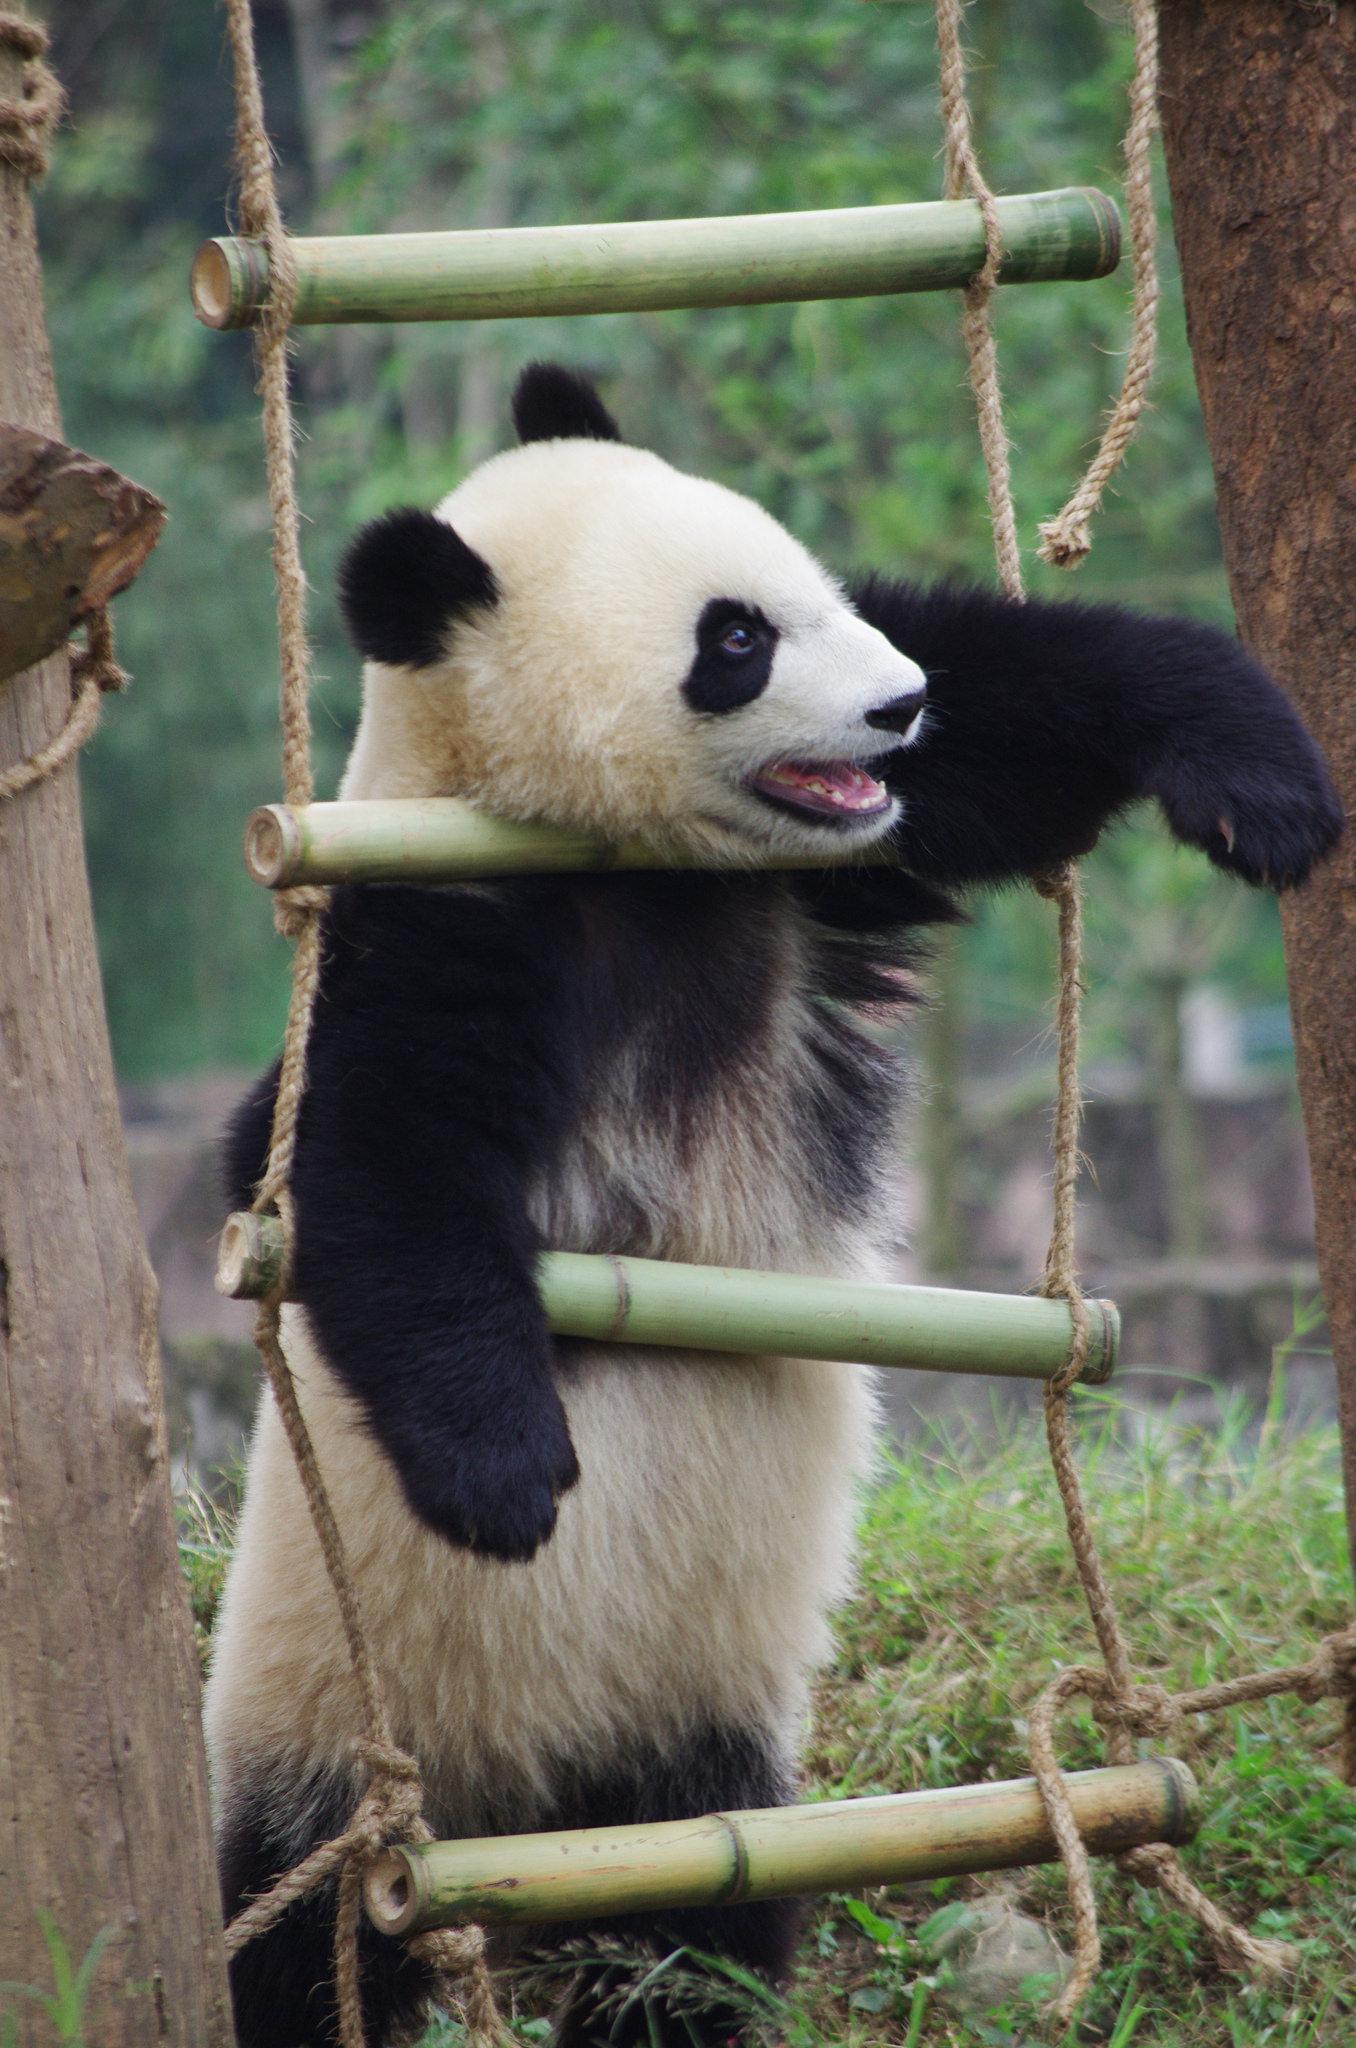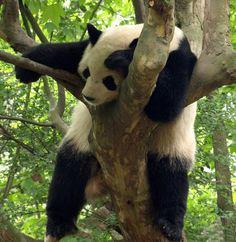The first image is the image on the left, the second image is the image on the right. Assess this claim about the two images: "The right image shows one panda draped over part of a tree, with its hind legs hanging down.". Correct or not? Answer yes or no. Yes. The first image is the image on the left, the second image is the image on the right. Evaluate the accuracy of this statement regarding the images: "The panda in the image on the left is hanging against the side of a tree trunk.". Is it true? Answer yes or no. No. 